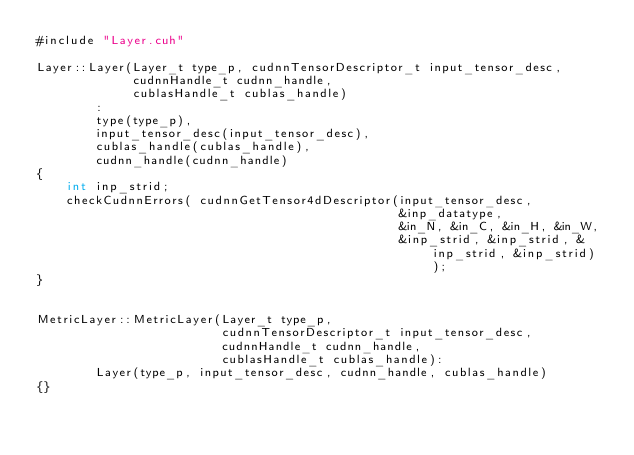<code> <loc_0><loc_0><loc_500><loc_500><_Cuda_>#include "Layer.cuh"

Layer::Layer(Layer_t type_p, cudnnTensorDescriptor_t input_tensor_desc,
             cudnnHandle_t cudnn_handle,
             cublasHandle_t cublas_handle)
        :
        type(type_p),
        input_tensor_desc(input_tensor_desc),
        cublas_handle(cublas_handle),
        cudnn_handle(cudnn_handle)
{
    int inp_strid;
    checkCudnnErrors( cudnnGetTensor4dDescriptor(input_tensor_desc,
                                                 &inp_datatype,
                                                 &in_N, &in_C, &in_H, &in_W,
                                                 &inp_strid, &inp_strid, &inp_strid, &inp_strid) );
}


MetricLayer::MetricLayer(Layer_t type_p,
                         cudnnTensorDescriptor_t input_tensor_desc,
                         cudnnHandle_t cudnn_handle,
                         cublasHandle_t cublas_handle):
        Layer(type_p, input_tensor_desc, cudnn_handle, cublas_handle)
{}</code> 